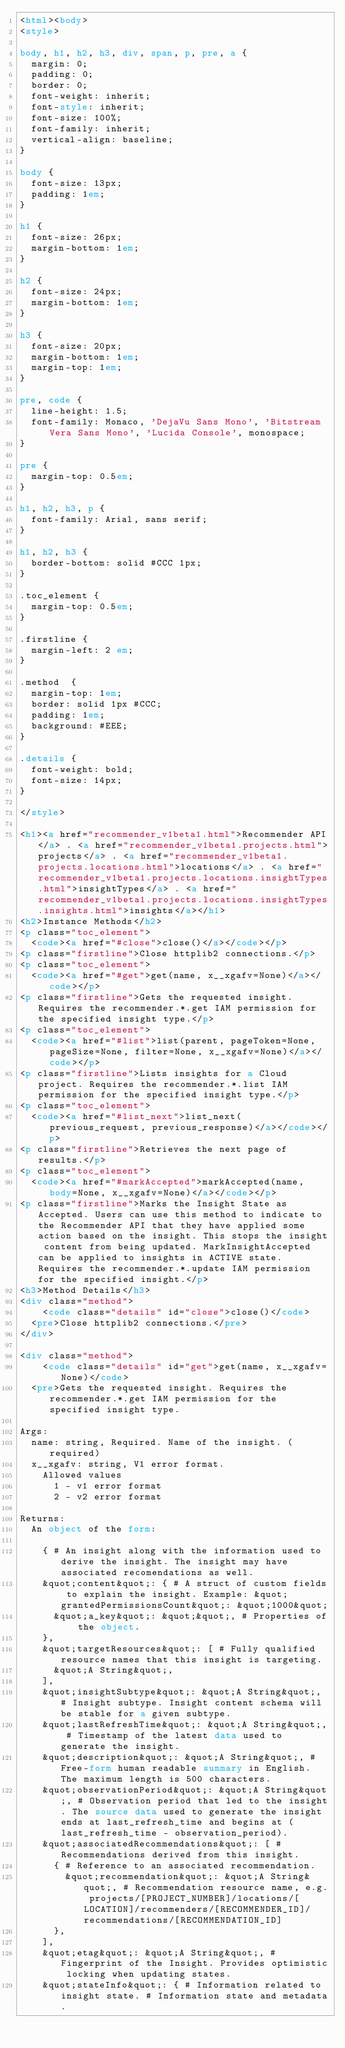Convert code to text. <code><loc_0><loc_0><loc_500><loc_500><_HTML_><html><body>
<style>

body, h1, h2, h3, div, span, p, pre, a {
  margin: 0;
  padding: 0;
  border: 0;
  font-weight: inherit;
  font-style: inherit;
  font-size: 100%;
  font-family: inherit;
  vertical-align: baseline;
}

body {
  font-size: 13px;
  padding: 1em;
}

h1 {
  font-size: 26px;
  margin-bottom: 1em;
}

h2 {
  font-size: 24px;
  margin-bottom: 1em;
}

h3 {
  font-size: 20px;
  margin-bottom: 1em;
  margin-top: 1em;
}

pre, code {
  line-height: 1.5;
  font-family: Monaco, 'DejaVu Sans Mono', 'Bitstream Vera Sans Mono', 'Lucida Console', monospace;
}

pre {
  margin-top: 0.5em;
}

h1, h2, h3, p {
  font-family: Arial, sans serif;
}

h1, h2, h3 {
  border-bottom: solid #CCC 1px;
}

.toc_element {
  margin-top: 0.5em;
}

.firstline {
  margin-left: 2 em;
}

.method  {
  margin-top: 1em;
  border: solid 1px #CCC;
  padding: 1em;
  background: #EEE;
}

.details {
  font-weight: bold;
  font-size: 14px;
}

</style>

<h1><a href="recommender_v1beta1.html">Recommender API</a> . <a href="recommender_v1beta1.projects.html">projects</a> . <a href="recommender_v1beta1.projects.locations.html">locations</a> . <a href="recommender_v1beta1.projects.locations.insightTypes.html">insightTypes</a> . <a href="recommender_v1beta1.projects.locations.insightTypes.insights.html">insights</a></h1>
<h2>Instance Methods</h2>
<p class="toc_element">
  <code><a href="#close">close()</a></code></p>
<p class="firstline">Close httplib2 connections.</p>
<p class="toc_element">
  <code><a href="#get">get(name, x__xgafv=None)</a></code></p>
<p class="firstline">Gets the requested insight. Requires the recommender.*.get IAM permission for the specified insight type.</p>
<p class="toc_element">
  <code><a href="#list">list(parent, pageToken=None, pageSize=None, filter=None, x__xgafv=None)</a></code></p>
<p class="firstline">Lists insights for a Cloud project. Requires the recommender.*.list IAM permission for the specified insight type.</p>
<p class="toc_element">
  <code><a href="#list_next">list_next(previous_request, previous_response)</a></code></p>
<p class="firstline">Retrieves the next page of results.</p>
<p class="toc_element">
  <code><a href="#markAccepted">markAccepted(name, body=None, x__xgafv=None)</a></code></p>
<p class="firstline">Marks the Insight State as Accepted. Users can use this method to indicate to the Recommender API that they have applied some action based on the insight. This stops the insight content from being updated. MarkInsightAccepted can be applied to insights in ACTIVE state. Requires the recommender.*.update IAM permission for the specified insight.</p>
<h3>Method Details</h3>
<div class="method">
    <code class="details" id="close">close()</code>
  <pre>Close httplib2 connections.</pre>
</div>

<div class="method">
    <code class="details" id="get">get(name, x__xgafv=None)</code>
  <pre>Gets the requested insight. Requires the recommender.*.get IAM permission for the specified insight type.

Args:
  name: string, Required. Name of the insight. (required)
  x__xgafv: string, V1 error format.
    Allowed values
      1 - v1 error format
      2 - v2 error format

Returns:
  An object of the form:

    { # An insight along with the information used to derive the insight. The insight may have associated recomendations as well.
    &quot;content&quot;: { # A struct of custom fields to explain the insight. Example: &quot;grantedPermissionsCount&quot;: &quot;1000&quot;
      &quot;a_key&quot;: &quot;&quot;, # Properties of the object.
    },
    &quot;targetResources&quot;: [ # Fully qualified resource names that this insight is targeting.
      &quot;A String&quot;,
    ],
    &quot;insightSubtype&quot;: &quot;A String&quot;, # Insight subtype. Insight content schema will be stable for a given subtype.
    &quot;lastRefreshTime&quot;: &quot;A String&quot;, # Timestamp of the latest data used to generate the insight.
    &quot;description&quot;: &quot;A String&quot;, # Free-form human readable summary in English. The maximum length is 500 characters.
    &quot;observationPeriod&quot;: &quot;A String&quot;, # Observation period that led to the insight. The source data used to generate the insight ends at last_refresh_time and begins at (last_refresh_time - observation_period).
    &quot;associatedRecommendations&quot;: [ # Recommendations derived from this insight.
      { # Reference to an associated recommendation.
        &quot;recommendation&quot;: &quot;A String&quot;, # Recommendation resource name, e.g. projects/[PROJECT_NUMBER]/locations/[LOCATION]/recommenders/[RECOMMENDER_ID]/recommendations/[RECOMMENDATION_ID]
      },
    ],
    &quot;etag&quot;: &quot;A String&quot;, # Fingerprint of the Insight. Provides optimistic locking when updating states.
    &quot;stateInfo&quot;: { # Information related to insight state. # Information state and metadata.</code> 